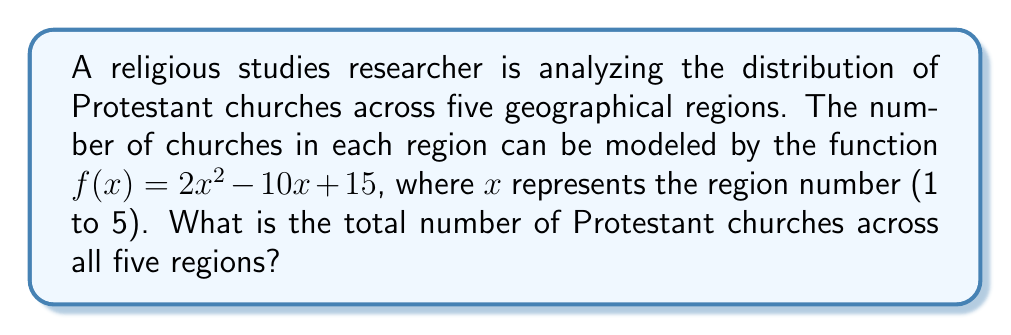What is the answer to this math problem? To solve this problem, we need to follow these steps:

1) The function $f(x) = 2x^2 - 10x + 15$ gives the number of churches for each region $x$.

2) We need to calculate $f(x)$ for $x = 1, 2, 3, 4,$ and $5$, then sum the results.

3) Let's calculate each:

   For $x = 1$: $f(1) = 2(1)^2 - 10(1) + 15 = 2 - 10 + 15 = 7$
   For $x = 2$: $f(2) = 2(2)^2 - 10(2) + 15 = 8 - 20 + 15 = 3$
   For $x = 3$: $f(3) = 2(3)^2 - 10(3) + 15 = 18 - 30 + 15 = 3$
   For $x = 4$: $f(4) = 2(4)^2 - 10(4) + 15 = 32 - 40 + 15 = 7$
   For $x = 5$: $f(5) = 2(5)^2 - 10(5) + 15 = 50 - 50 + 15 = 15$

4) Now, we sum all these values:

   Total = $7 + 3 + 3 + 7 + 15 = 35$

Therefore, the total number of Protestant churches across all five regions is 35.
Answer: 35 